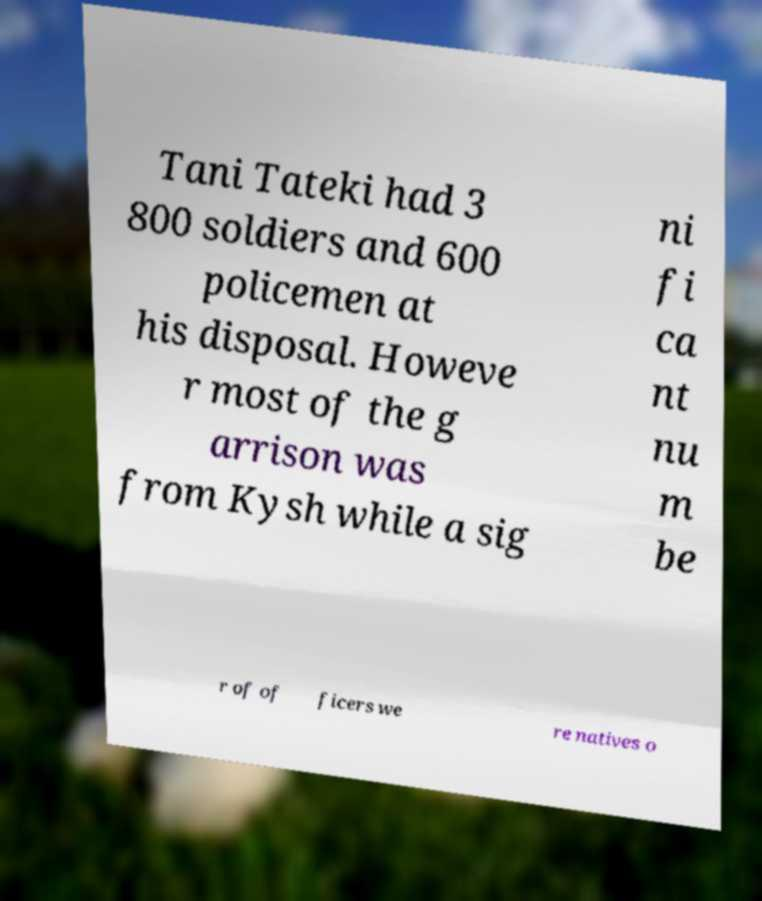I need the written content from this picture converted into text. Can you do that? Tani Tateki had 3 800 soldiers and 600 policemen at his disposal. Howeve r most of the g arrison was from Kysh while a sig ni fi ca nt nu m be r of of ficers we re natives o 